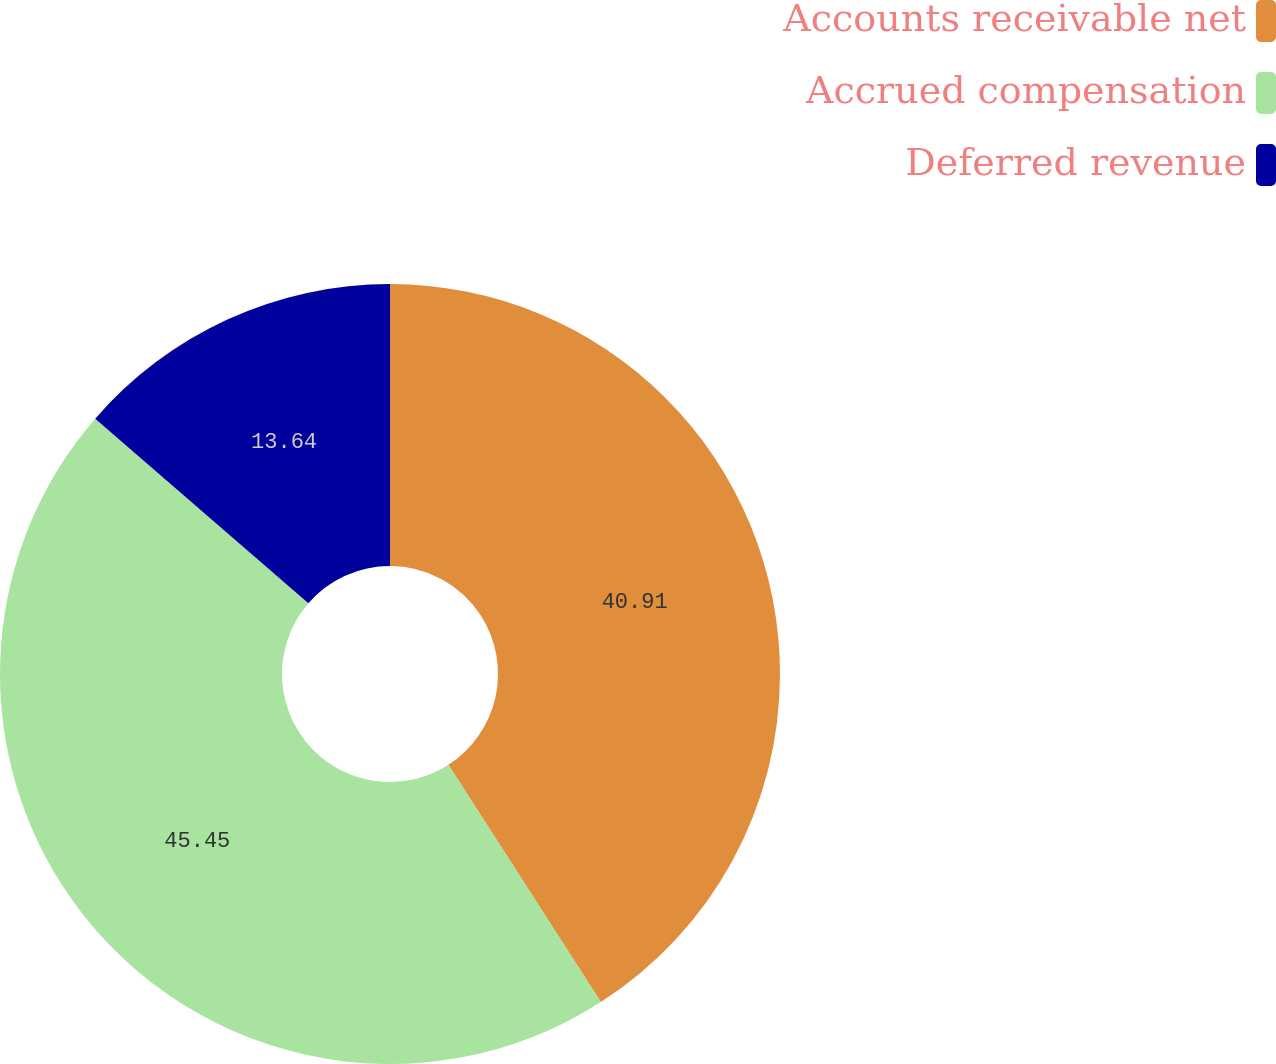<chart> <loc_0><loc_0><loc_500><loc_500><pie_chart><fcel>Accounts receivable net<fcel>Accrued compensation<fcel>Deferred revenue<nl><fcel>40.91%<fcel>45.45%<fcel>13.64%<nl></chart> 